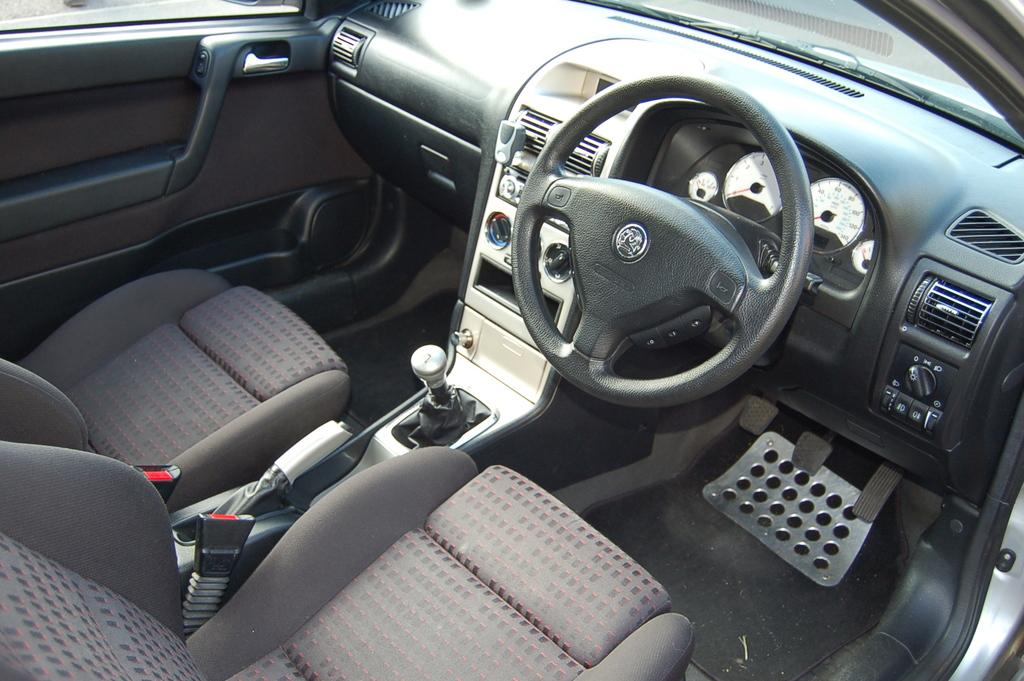What type of space is shown in the image? The image is an interior view of a car. What can be seen through the front of the car? There is a windshield in the car. What is used to control the direction of the car? There is a steering wheel in the car. How many seats are visible in the car? There are seats in the car. What is used to change gears in the car? There is a clutch, a brake, and a gear lever in the car. How is air circulated in the car? There is an air vent in the car. How are the doors of the car opened and closed? There are door handles in the car. What type of crib is visible in the image? There is no crib present in the image; it is an interior view of a car. How many bulbs are used to light up the car in the image? There is no mention of bulbs or lighting in the image; it is focused on the car's interior components. 